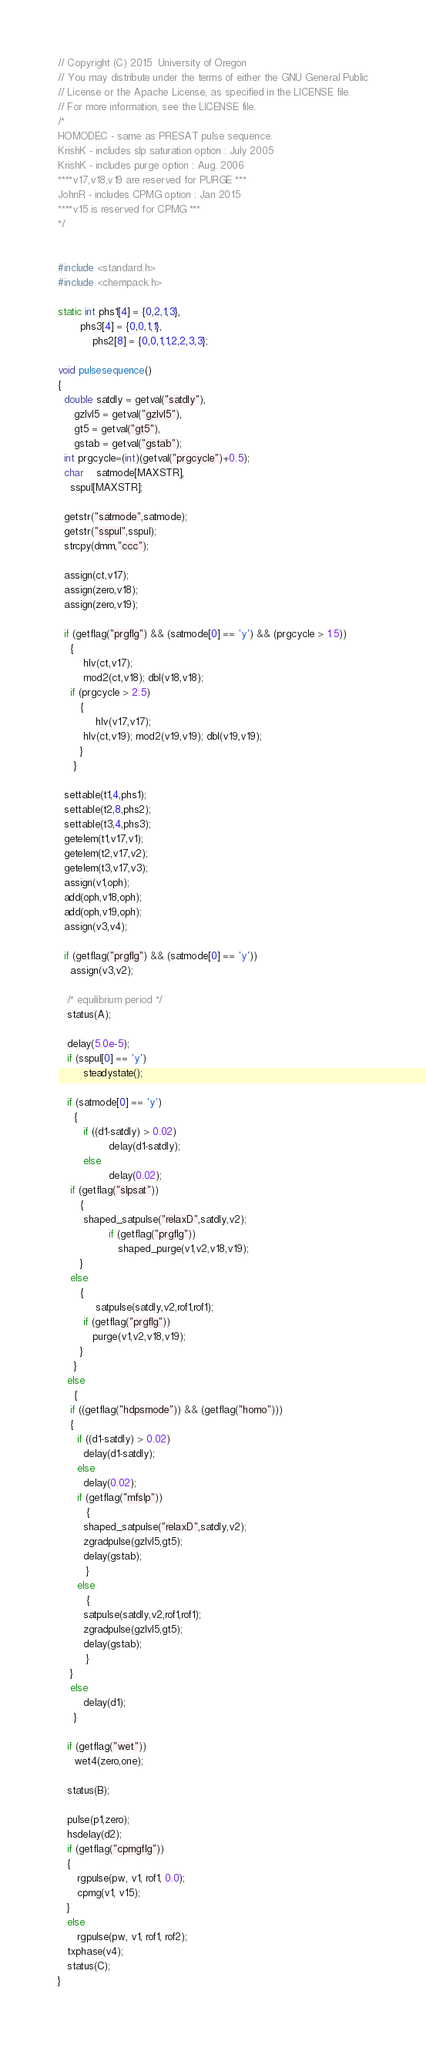<code> <loc_0><loc_0><loc_500><loc_500><_C_>// Copyright (C) 2015  University of Oregon
// You may distribute under the terms of either the GNU General Public
// License or the Apache License, as specified in the LICENSE file.
// For more information, see the LICENSE file.
/*
HOMODEC - same as PRESAT pulse sequence.  
KrishK - includes slp saturation option : July 2005
KrishK - includes purge option : Aug. 2006
****v17,v18,v19 are reserved for PURGE ***
JohnR - includes CPMG option : Jan 2015
****v15 is reserved for CPMG ***
*/


#include <standard.h>
#include <chempack.h>

static int phs1[4] = {0,2,1,3},
	   phs3[4] = {0,0,1,1},
           phs2[8] = {0,0,1,1,2,2,3,3};

void pulsesequence()
{
  double satdly = getval("satdly"),
	 gzlvl5 = getval("gzlvl5"),
	 gt5 = getval("gt5"),
	 gstab = getval("gstab");
  int prgcycle=(int)(getval("prgcycle")+0.5);
  char	satmode[MAXSTR],
	sspul[MAXSTR];

  getstr("satmode",satmode);
  getstr("sspul",sspul);
  strcpy(dmm,"ccc");

  assign(ct,v17);
  assign(zero,v18);
  assign(zero,v19);

  if (getflag("prgflg") && (satmode[0] == 'y') && (prgcycle > 1.5))
    {
        hlv(ct,v17);
        mod2(ct,v18); dbl(v18,v18);
  	if (prgcycle > 2.5)
	   {
        	hlv(v17,v17);
		hlv(ct,v19); mod2(v19,v19); dbl(v19,v19);
	   }
     }

  settable(t1,4,phs1);
  settable(t2,8,phs2);
  settable(t3,4,phs3);
  getelem(t1,v17,v1);
  getelem(t2,v17,v2);
  getelem(t3,v17,v3);
  assign(v1,oph);
  add(oph,v18,oph);
  add(oph,v19,oph);
  assign(v3,v4);

  if (getflag("prgflg") && (satmode[0] == 'y'))
	assign(v3,v2);

   /* equilibrium period */
   status(A);

   delay(5.0e-5);
   if (sspul[0] == 'y')
        steadystate();

   if (satmode[0] == 'y')
     {
        if ((d1-satdly) > 0.02)
                delay(d1-satdly);
        else
                delay(0.02);
	if (getflag("slpsat"))
	   {
		shaped_satpulse("relaxD",satdly,v2);
                if (getflag("prgflg"))
                   shaped_purge(v1,v2,v18,v19);
	   }
	else
	   {
        	satpulse(satdly,v2,rof1,rof1);
		if (getflag("prgflg"))
		   purge(v1,v2,v18,v19);
	   }
     }
   else
     {
	if ((getflag("hdpsmode")) && (getflag("homo")))
	{
	  if ((d1-satdly) > 0.02)
		delay(d1-satdly);
	  else
		delay(0.02);
	  if (getflag("mfslp"))
	     {
		shaped_satpulse("relaxD",satdly,v2);
		zgradpulse(gzlvl5,gt5);
	 	delay(gstab);
	     }
	  else
	     {
		satpulse(satdly,v2,rof1,rof1);
		zgradpulse(gzlvl5,gt5);
		delay(gstab);
	     }
	}
	else
		delay(d1);
     }

   if (getflag("wet"))
     wet4(zero,one);

   status(B);

   pulse(p1,zero); 
   hsdelay(d2); 
   if (getflag("cpmgflg"))
   {
      rgpulse(pw, v1, rof1, 0.0);
      cpmg(v1, v15);
   }
   else
      rgpulse(pw, v1, rof1, rof2);
   txphase(v4);
   status(C);
}
</code> 